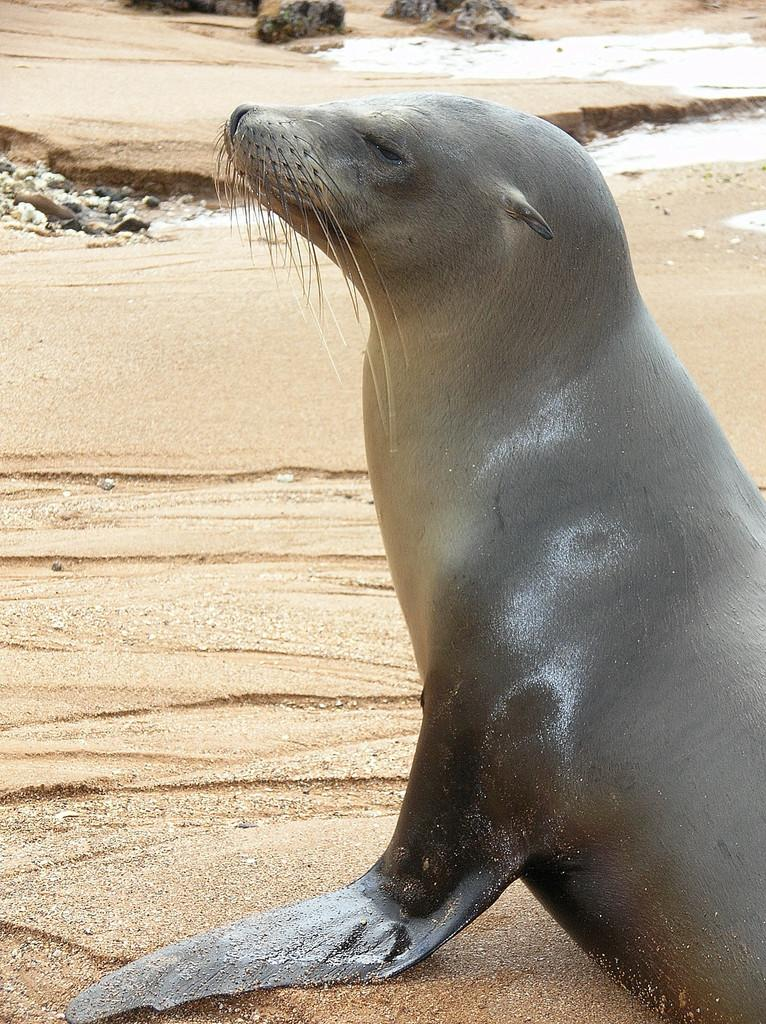What animal can be seen in the picture? There is a seal in the picture. What type of terrain is visible at the bottom of the image? There is sand at the bottom of the image. What other objects can be seen in the image? There are stones in the image. What natural element is visible in the image? There is water visible in the image. What type of pin can be seen holding the knowledge in the image? There is no pin or knowledge present in the image; it features a seal, sand, stones, and water. 